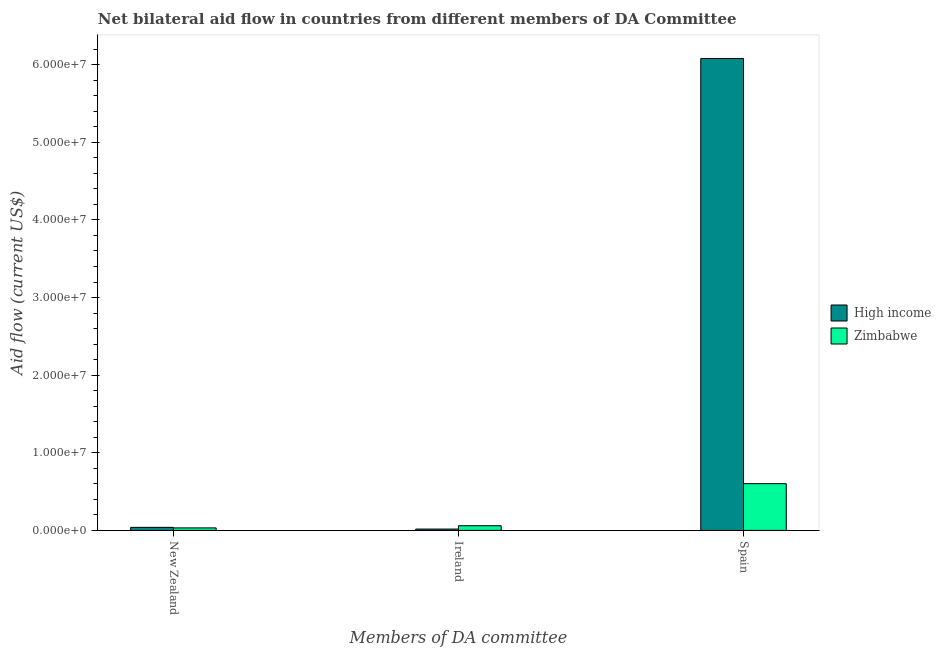How many different coloured bars are there?
Provide a succinct answer. 2. How many bars are there on the 1st tick from the left?
Provide a succinct answer. 2. How many bars are there on the 2nd tick from the right?
Make the answer very short. 2. What is the label of the 1st group of bars from the left?
Provide a succinct answer. New Zealand. What is the amount of aid provided by spain in Zimbabwe?
Your answer should be very brief. 6.02e+06. Across all countries, what is the maximum amount of aid provided by ireland?
Ensure brevity in your answer.  6.00e+05. Across all countries, what is the minimum amount of aid provided by spain?
Keep it short and to the point. 6.02e+06. In which country was the amount of aid provided by ireland maximum?
Provide a short and direct response. Zimbabwe. In which country was the amount of aid provided by spain minimum?
Provide a succinct answer. Zimbabwe. What is the total amount of aid provided by new zealand in the graph?
Give a very brief answer. 7.10e+05. What is the difference between the amount of aid provided by ireland in Zimbabwe and that in High income?
Keep it short and to the point. 4.30e+05. What is the difference between the amount of aid provided by spain in Zimbabwe and the amount of aid provided by new zealand in High income?
Offer a very short reply. 5.63e+06. What is the average amount of aid provided by spain per country?
Offer a terse response. 3.34e+07. What is the difference between the amount of aid provided by spain and amount of aid provided by new zealand in High income?
Your response must be concise. 6.04e+07. In how many countries, is the amount of aid provided by spain greater than 54000000 US$?
Ensure brevity in your answer.  1. What is the ratio of the amount of aid provided by ireland in Zimbabwe to that in High income?
Your response must be concise. 3.53. Is the amount of aid provided by new zealand in High income less than that in Zimbabwe?
Provide a succinct answer. No. What is the difference between the highest and the second highest amount of aid provided by new zealand?
Your answer should be compact. 7.00e+04. What is the difference between the highest and the lowest amount of aid provided by spain?
Give a very brief answer. 5.48e+07. Is the sum of the amount of aid provided by new zealand in High income and Zimbabwe greater than the maximum amount of aid provided by ireland across all countries?
Provide a succinct answer. Yes. What does the 1st bar from the left in Ireland represents?
Offer a terse response. High income. What does the 1st bar from the right in Spain represents?
Your answer should be compact. Zimbabwe. Is it the case that in every country, the sum of the amount of aid provided by new zealand and amount of aid provided by ireland is greater than the amount of aid provided by spain?
Your response must be concise. No. How many countries are there in the graph?
Your answer should be compact. 2. Are the values on the major ticks of Y-axis written in scientific E-notation?
Offer a very short reply. Yes. Does the graph contain any zero values?
Ensure brevity in your answer.  No. What is the title of the graph?
Provide a short and direct response. Net bilateral aid flow in countries from different members of DA Committee. Does "Maldives" appear as one of the legend labels in the graph?
Ensure brevity in your answer.  No. What is the label or title of the X-axis?
Your response must be concise. Members of DA committee. What is the Aid flow (current US$) of High income in New Zealand?
Keep it short and to the point. 3.90e+05. What is the Aid flow (current US$) of Zimbabwe in Ireland?
Your response must be concise. 6.00e+05. What is the Aid flow (current US$) of High income in Spain?
Offer a terse response. 6.08e+07. What is the Aid flow (current US$) of Zimbabwe in Spain?
Ensure brevity in your answer.  6.02e+06. Across all Members of DA committee, what is the maximum Aid flow (current US$) of High income?
Your response must be concise. 6.08e+07. Across all Members of DA committee, what is the maximum Aid flow (current US$) of Zimbabwe?
Your response must be concise. 6.02e+06. What is the total Aid flow (current US$) of High income in the graph?
Provide a short and direct response. 6.14e+07. What is the total Aid flow (current US$) of Zimbabwe in the graph?
Keep it short and to the point. 6.94e+06. What is the difference between the Aid flow (current US$) in Zimbabwe in New Zealand and that in Ireland?
Offer a terse response. -2.80e+05. What is the difference between the Aid flow (current US$) of High income in New Zealand and that in Spain?
Ensure brevity in your answer.  -6.04e+07. What is the difference between the Aid flow (current US$) in Zimbabwe in New Zealand and that in Spain?
Offer a terse response. -5.70e+06. What is the difference between the Aid flow (current US$) of High income in Ireland and that in Spain?
Your response must be concise. -6.06e+07. What is the difference between the Aid flow (current US$) in Zimbabwe in Ireland and that in Spain?
Your answer should be compact. -5.42e+06. What is the difference between the Aid flow (current US$) in High income in New Zealand and the Aid flow (current US$) in Zimbabwe in Spain?
Keep it short and to the point. -5.63e+06. What is the difference between the Aid flow (current US$) of High income in Ireland and the Aid flow (current US$) of Zimbabwe in Spain?
Your response must be concise. -5.85e+06. What is the average Aid flow (current US$) of High income per Members of DA committee?
Provide a short and direct response. 2.05e+07. What is the average Aid flow (current US$) of Zimbabwe per Members of DA committee?
Offer a terse response. 2.31e+06. What is the difference between the Aid flow (current US$) in High income and Aid flow (current US$) in Zimbabwe in New Zealand?
Make the answer very short. 7.00e+04. What is the difference between the Aid flow (current US$) in High income and Aid flow (current US$) in Zimbabwe in Ireland?
Provide a short and direct response. -4.30e+05. What is the difference between the Aid flow (current US$) in High income and Aid flow (current US$) in Zimbabwe in Spain?
Your response must be concise. 5.48e+07. What is the ratio of the Aid flow (current US$) in High income in New Zealand to that in Ireland?
Your answer should be very brief. 2.29. What is the ratio of the Aid flow (current US$) of Zimbabwe in New Zealand to that in Ireland?
Your answer should be very brief. 0.53. What is the ratio of the Aid flow (current US$) of High income in New Zealand to that in Spain?
Make the answer very short. 0.01. What is the ratio of the Aid flow (current US$) in Zimbabwe in New Zealand to that in Spain?
Keep it short and to the point. 0.05. What is the ratio of the Aid flow (current US$) of High income in Ireland to that in Spain?
Offer a very short reply. 0. What is the ratio of the Aid flow (current US$) of Zimbabwe in Ireland to that in Spain?
Offer a terse response. 0.1. What is the difference between the highest and the second highest Aid flow (current US$) in High income?
Keep it short and to the point. 6.04e+07. What is the difference between the highest and the second highest Aid flow (current US$) of Zimbabwe?
Provide a succinct answer. 5.42e+06. What is the difference between the highest and the lowest Aid flow (current US$) of High income?
Provide a succinct answer. 6.06e+07. What is the difference between the highest and the lowest Aid flow (current US$) in Zimbabwe?
Offer a very short reply. 5.70e+06. 